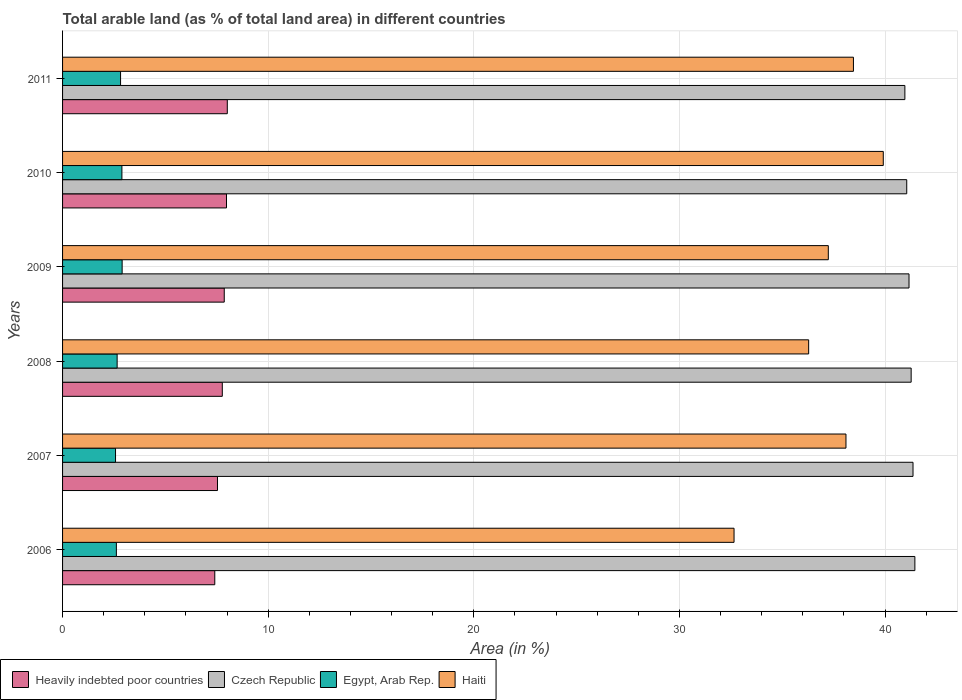How many different coloured bars are there?
Your answer should be compact. 4. How many bars are there on the 4th tick from the top?
Offer a terse response. 4. What is the percentage of arable land in Heavily indebted poor countries in 2009?
Keep it short and to the point. 7.86. Across all years, what is the maximum percentage of arable land in Czech Republic?
Your answer should be compact. 41.45. Across all years, what is the minimum percentage of arable land in Egypt, Arab Rep.?
Keep it short and to the point. 2.58. In which year was the percentage of arable land in Czech Republic minimum?
Your answer should be compact. 2011. What is the total percentage of arable land in Czech Republic in the graph?
Give a very brief answer. 247.26. What is the difference between the percentage of arable land in Egypt, Arab Rep. in 2010 and that in 2011?
Your answer should be compact. 0.07. What is the difference between the percentage of arable land in Haiti in 2010 and the percentage of arable land in Czech Republic in 2008?
Give a very brief answer. -1.36. What is the average percentage of arable land in Egypt, Arab Rep. per year?
Offer a terse response. 2.74. In the year 2008, what is the difference between the percentage of arable land in Heavily indebted poor countries and percentage of arable land in Czech Republic?
Keep it short and to the point. -33.5. In how many years, is the percentage of arable land in Haiti greater than 24 %?
Your answer should be very brief. 6. What is the ratio of the percentage of arable land in Haiti in 2006 to that in 2007?
Give a very brief answer. 0.86. Is the percentage of arable land in Czech Republic in 2008 less than that in 2011?
Make the answer very short. No. What is the difference between the highest and the second highest percentage of arable land in Heavily indebted poor countries?
Provide a short and direct response. 0.04. What is the difference between the highest and the lowest percentage of arable land in Egypt, Arab Rep.?
Your response must be concise. 0.32. What does the 2nd bar from the top in 2007 represents?
Give a very brief answer. Egypt, Arab Rep. What does the 2nd bar from the bottom in 2011 represents?
Make the answer very short. Czech Republic. How many bars are there?
Keep it short and to the point. 24. How many years are there in the graph?
Your response must be concise. 6. What is the difference between two consecutive major ticks on the X-axis?
Your answer should be very brief. 10. Are the values on the major ticks of X-axis written in scientific E-notation?
Make the answer very short. No. Does the graph contain any zero values?
Your response must be concise. No. Does the graph contain grids?
Your answer should be compact. Yes. Where does the legend appear in the graph?
Give a very brief answer. Bottom left. How many legend labels are there?
Give a very brief answer. 4. What is the title of the graph?
Your response must be concise. Total arable land (as % of total land area) in different countries. What is the label or title of the X-axis?
Offer a terse response. Area (in %). What is the label or title of the Y-axis?
Provide a succinct answer. Years. What is the Area (in %) in Heavily indebted poor countries in 2006?
Make the answer very short. 7.4. What is the Area (in %) in Czech Republic in 2006?
Your response must be concise. 41.45. What is the Area (in %) of Egypt, Arab Rep. in 2006?
Your answer should be compact. 2.62. What is the Area (in %) of Haiti in 2006?
Give a very brief answer. 32.66. What is the Area (in %) in Heavily indebted poor countries in 2007?
Provide a succinct answer. 7.53. What is the Area (in %) in Czech Republic in 2007?
Make the answer very short. 41.36. What is the Area (in %) of Egypt, Arab Rep. in 2007?
Offer a terse response. 2.58. What is the Area (in %) in Haiti in 2007?
Your answer should be compact. 38.1. What is the Area (in %) in Heavily indebted poor countries in 2008?
Offer a terse response. 7.77. What is the Area (in %) of Czech Republic in 2008?
Ensure brevity in your answer.  41.27. What is the Area (in %) of Egypt, Arab Rep. in 2008?
Make the answer very short. 2.65. What is the Area (in %) of Haiti in 2008?
Offer a terse response. 36.28. What is the Area (in %) of Heavily indebted poor countries in 2009?
Your answer should be very brief. 7.86. What is the Area (in %) of Czech Republic in 2009?
Provide a short and direct response. 41.17. What is the Area (in %) of Egypt, Arab Rep. in 2009?
Provide a succinct answer. 2.9. What is the Area (in %) of Haiti in 2009?
Provide a succinct answer. 37.24. What is the Area (in %) of Heavily indebted poor countries in 2010?
Your answer should be compact. 7.97. What is the Area (in %) in Czech Republic in 2010?
Offer a very short reply. 41.05. What is the Area (in %) of Egypt, Arab Rep. in 2010?
Your answer should be compact. 2.89. What is the Area (in %) of Haiti in 2010?
Make the answer very short. 39.91. What is the Area (in %) in Heavily indebted poor countries in 2011?
Offer a terse response. 8.01. What is the Area (in %) of Czech Republic in 2011?
Provide a short and direct response. 40.96. What is the Area (in %) in Egypt, Arab Rep. in 2011?
Offer a very short reply. 2.82. What is the Area (in %) of Haiti in 2011?
Ensure brevity in your answer.  38.46. Across all years, what is the maximum Area (in %) of Heavily indebted poor countries?
Ensure brevity in your answer.  8.01. Across all years, what is the maximum Area (in %) of Czech Republic?
Your answer should be compact. 41.45. Across all years, what is the maximum Area (in %) of Egypt, Arab Rep.?
Ensure brevity in your answer.  2.9. Across all years, what is the maximum Area (in %) in Haiti?
Your answer should be compact. 39.91. Across all years, what is the minimum Area (in %) in Heavily indebted poor countries?
Offer a terse response. 7.4. Across all years, what is the minimum Area (in %) in Czech Republic?
Provide a succinct answer. 40.96. Across all years, what is the minimum Area (in %) of Egypt, Arab Rep.?
Make the answer very short. 2.58. Across all years, what is the minimum Area (in %) of Haiti?
Provide a short and direct response. 32.66. What is the total Area (in %) of Heavily indebted poor countries in the graph?
Your answer should be very brief. 46.55. What is the total Area (in %) in Czech Republic in the graph?
Ensure brevity in your answer.  247.26. What is the total Area (in %) in Egypt, Arab Rep. in the graph?
Provide a succinct answer. 16.45. What is the total Area (in %) of Haiti in the graph?
Your response must be concise. 222.65. What is the difference between the Area (in %) in Heavily indebted poor countries in 2006 and that in 2007?
Provide a succinct answer. -0.13. What is the difference between the Area (in %) of Czech Republic in 2006 and that in 2007?
Offer a very short reply. 0.09. What is the difference between the Area (in %) of Egypt, Arab Rep. in 2006 and that in 2007?
Offer a very short reply. 0.04. What is the difference between the Area (in %) of Haiti in 2006 and that in 2007?
Keep it short and to the point. -5.44. What is the difference between the Area (in %) of Heavily indebted poor countries in 2006 and that in 2008?
Provide a succinct answer. -0.37. What is the difference between the Area (in %) in Czech Republic in 2006 and that in 2008?
Keep it short and to the point. 0.18. What is the difference between the Area (in %) of Egypt, Arab Rep. in 2006 and that in 2008?
Ensure brevity in your answer.  -0.04. What is the difference between the Area (in %) of Haiti in 2006 and that in 2008?
Your answer should be very brief. -3.63. What is the difference between the Area (in %) of Heavily indebted poor countries in 2006 and that in 2009?
Your response must be concise. -0.46. What is the difference between the Area (in %) in Czech Republic in 2006 and that in 2009?
Offer a terse response. 0.28. What is the difference between the Area (in %) in Egypt, Arab Rep. in 2006 and that in 2009?
Ensure brevity in your answer.  -0.28. What is the difference between the Area (in %) of Haiti in 2006 and that in 2009?
Offer a very short reply. -4.58. What is the difference between the Area (in %) in Heavily indebted poor countries in 2006 and that in 2010?
Your answer should be compact. -0.57. What is the difference between the Area (in %) in Czech Republic in 2006 and that in 2010?
Provide a short and direct response. 0.4. What is the difference between the Area (in %) in Egypt, Arab Rep. in 2006 and that in 2010?
Give a very brief answer. -0.27. What is the difference between the Area (in %) in Haiti in 2006 and that in 2010?
Ensure brevity in your answer.  -7.26. What is the difference between the Area (in %) of Heavily indebted poor countries in 2006 and that in 2011?
Provide a short and direct response. -0.61. What is the difference between the Area (in %) in Czech Republic in 2006 and that in 2011?
Make the answer very short. 0.49. What is the difference between the Area (in %) of Egypt, Arab Rep. in 2006 and that in 2011?
Provide a succinct answer. -0.2. What is the difference between the Area (in %) of Haiti in 2006 and that in 2011?
Provide a succinct answer. -5.81. What is the difference between the Area (in %) of Heavily indebted poor countries in 2007 and that in 2008?
Provide a short and direct response. -0.23. What is the difference between the Area (in %) of Czech Republic in 2007 and that in 2008?
Offer a very short reply. 0.09. What is the difference between the Area (in %) of Egypt, Arab Rep. in 2007 and that in 2008?
Your answer should be compact. -0.08. What is the difference between the Area (in %) in Haiti in 2007 and that in 2008?
Your answer should be compact. 1.81. What is the difference between the Area (in %) of Heavily indebted poor countries in 2007 and that in 2009?
Provide a succinct answer. -0.33. What is the difference between the Area (in %) in Czech Republic in 2007 and that in 2009?
Keep it short and to the point. 0.19. What is the difference between the Area (in %) of Egypt, Arab Rep. in 2007 and that in 2009?
Provide a short and direct response. -0.32. What is the difference between the Area (in %) of Haiti in 2007 and that in 2009?
Offer a very short reply. 0.86. What is the difference between the Area (in %) of Heavily indebted poor countries in 2007 and that in 2010?
Offer a terse response. -0.44. What is the difference between the Area (in %) in Czech Republic in 2007 and that in 2010?
Give a very brief answer. 0.31. What is the difference between the Area (in %) of Egypt, Arab Rep. in 2007 and that in 2010?
Your answer should be compact. -0.31. What is the difference between the Area (in %) of Haiti in 2007 and that in 2010?
Provide a succinct answer. -1.81. What is the difference between the Area (in %) in Heavily indebted poor countries in 2007 and that in 2011?
Keep it short and to the point. -0.48. What is the difference between the Area (in %) of Czech Republic in 2007 and that in 2011?
Your answer should be compact. 0.4. What is the difference between the Area (in %) of Egypt, Arab Rep. in 2007 and that in 2011?
Keep it short and to the point. -0.25. What is the difference between the Area (in %) in Haiti in 2007 and that in 2011?
Your response must be concise. -0.36. What is the difference between the Area (in %) of Heavily indebted poor countries in 2008 and that in 2009?
Provide a short and direct response. -0.09. What is the difference between the Area (in %) in Czech Republic in 2008 and that in 2009?
Ensure brevity in your answer.  0.1. What is the difference between the Area (in %) of Egypt, Arab Rep. in 2008 and that in 2009?
Give a very brief answer. -0.24. What is the difference between the Area (in %) in Haiti in 2008 and that in 2009?
Ensure brevity in your answer.  -0.96. What is the difference between the Area (in %) in Heavily indebted poor countries in 2008 and that in 2010?
Provide a succinct answer. -0.2. What is the difference between the Area (in %) of Czech Republic in 2008 and that in 2010?
Your answer should be very brief. 0.21. What is the difference between the Area (in %) in Egypt, Arab Rep. in 2008 and that in 2010?
Your response must be concise. -0.23. What is the difference between the Area (in %) in Haiti in 2008 and that in 2010?
Offer a very short reply. -3.63. What is the difference between the Area (in %) in Heavily indebted poor countries in 2008 and that in 2011?
Offer a very short reply. -0.24. What is the difference between the Area (in %) of Czech Republic in 2008 and that in 2011?
Offer a terse response. 0.31. What is the difference between the Area (in %) of Egypt, Arab Rep. in 2008 and that in 2011?
Offer a terse response. -0.17. What is the difference between the Area (in %) of Haiti in 2008 and that in 2011?
Ensure brevity in your answer.  -2.18. What is the difference between the Area (in %) in Heavily indebted poor countries in 2009 and that in 2010?
Your answer should be compact. -0.11. What is the difference between the Area (in %) in Czech Republic in 2009 and that in 2010?
Offer a terse response. 0.11. What is the difference between the Area (in %) in Egypt, Arab Rep. in 2009 and that in 2010?
Provide a succinct answer. 0.01. What is the difference between the Area (in %) of Haiti in 2009 and that in 2010?
Provide a succinct answer. -2.67. What is the difference between the Area (in %) of Heavily indebted poor countries in 2009 and that in 2011?
Provide a short and direct response. -0.15. What is the difference between the Area (in %) of Czech Republic in 2009 and that in 2011?
Ensure brevity in your answer.  0.2. What is the difference between the Area (in %) in Egypt, Arab Rep. in 2009 and that in 2011?
Offer a terse response. 0.08. What is the difference between the Area (in %) of Haiti in 2009 and that in 2011?
Your answer should be very brief. -1.22. What is the difference between the Area (in %) in Heavily indebted poor countries in 2010 and that in 2011?
Provide a short and direct response. -0.04. What is the difference between the Area (in %) in Czech Republic in 2010 and that in 2011?
Offer a terse response. 0.09. What is the difference between the Area (in %) in Egypt, Arab Rep. in 2010 and that in 2011?
Offer a very short reply. 0.07. What is the difference between the Area (in %) in Haiti in 2010 and that in 2011?
Offer a very short reply. 1.45. What is the difference between the Area (in %) of Heavily indebted poor countries in 2006 and the Area (in %) of Czech Republic in 2007?
Make the answer very short. -33.96. What is the difference between the Area (in %) of Heavily indebted poor countries in 2006 and the Area (in %) of Egypt, Arab Rep. in 2007?
Offer a very short reply. 4.83. What is the difference between the Area (in %) in Heavily indebted poor countries in 2006 and the Area (in %) in Haiti in 2007?
Your answer should be very brief. -30.7. What is the difference between the Area (in %) of Czech Republic in 2006 and the Area (in %) of Egypt, Arab Rep. in 2007?
Ensure brevity in your answer.  38.87. What is the difference between the Area (in %) in Czech Republic in 2006 and the Area (in %) in Haiti in 2007?
Give a very brief answer. 3.35. What is the difference between the Area (in %) in Egypt, Arab Rep. in 2006 and the Area (in %) in Haiti in 2007?
Offer a very short reply. -35.48. What is the difference between the Area (in %) in Heavily indebted poor countries in 2006 and the Area (in %) in Czech Republic in 2008?
Your answer should be compact. -33.87. What is the difference between the Area (in %) in Heavily indebted poor countries in 2006 and the Area (in %) in Egypt, Arab Rep. in 2008?
Your answer should be compact. 4.75. What is the difference between the Area (in %) of Heavily indebted poor countries in 2006 and the Area (in %) of Haiti in 2008?
Provide a succinct answer. -28.88. What is the difference between the Area (in %) in Czech Republic in 2006 and the Area (in %) in Egypt, Arab Rep. in 2008?
Keep it short and to the point. 38.8. What is the difference between the Area (in %) of Czech Republic in 2006 and the Area (in %) of Haiti in 2008?
Make the answer very short. 5.17. What is the difference between the Area (in %) in Egypt, Arab Rep. in 2006 and the Area (in %) in Haiti in 2008?
Give a very brief answer. -33.67. What is the difference between the Area (in %) of Heavily indebted poor countries in 2006 and the Area (in %) of Czech Republic in 2009?
Keep it short and to the point. -33.76. What is the difference between the Area (in %) of Heavily indebted poor countries in 2006 and the Area (in %) of Egypt, Arab Rep. in 2009?
Your answer should be very brief. 4.51. What is the difference between the Area (in %) in Heavily indebted poor countries in 2006 and the Area (in %) in Haiti in 2009?
Provide a succinct answer. -29.84. What is the difference between the Area (in %) in Czech Republic in 2006 and the Area (in %) in Egypt, Arab Rep. in 2009?
Make the answer very short. 38.55. What is the difference between the Area (in %) in Czech Republic in 2006 and the Area (in %) in Haiti in 2009?
Offer a very short reply. 4.21. What is the difference between the Area (in %) in Egypt, Arab Rep. in 2006 and the Area (in %) in Haiti in 2009?
Provide a short and direct response. -34.62. What is the difference between the Area (in %) of Heavily indebted poor countries in 2006 and the Area (in %) of Czech Republic in 2010?
Your response must be concise. -33.65. What is the difference between the Area (in %) of Heavily indebted poor countries in 2006 and the Area (in %) of Egypt, Arab Rep. in 2010?
Keep it short and to the point. 4.52. What is the difference between the Area (in %) of Heavily indebted poor countries in 2006 and the Area (in %) of Haiti in 2010?
Keep it short and to the point. -32.51. What is the difference between the Area (in %) of Czech Republic in 2006 and the Area (in %) of Egypt, Arab Rep. in 2010?
Give a very brief answer. 38.56. What is the difference between the Area (in %) in Czech Republic in 2006 and the Area (in %) in Haiti in 2010?
Offer a terse response. 1.54. What is the difference between the Area (in %) in Egypt, Arab Rep. in 2006 and the Area (in %) in Haiti in 2010?
Your answer should be very brief. -37.3. What is the difference between the Area (in %) in Heavily indebted poor countries in 2006 and the Area (in %) in Czech Republic in 2011?
Ensure brevity in your answer.  -33.56. What is the difference between the Area (in %) of Heavily indebted poor countries in 2006 and the Area (in %) of Egypt, Arab Rep. in 2011?
Offer a very short reply. 4.58. What is the difference between the Area (in %) in Heavily indebted poor countries in 2006 and the Area (in %) in Haiti in 2011?
Make the answer very short. -31.06. What is the difference between the Area (in %) of Czech Republic in 2006 and the Area (in %) of Egypt, Arab Rep. in 2011?
Ensure brevity in your answer.  38.63. What is the difference between the Area (in %) in Czech Republic in 2006 and the Area (in %) in Haiti in 2011?
Offer a very short reply. 2.99. What is the difference between the Area (in %) of Egypt, Arab Rep. in 2006 and the Area (in %) of Haiti in 2011?
Offer a terse response. -35.84. What is the difference between the Area (in %) of Heavily indebted poor countries in 2007 and the Area (in %) of Czech Republic in 2008?
Provide a short and direct response. -33.73. What is the difference between the Area (in %) of Heavily indebted poor countries in 2007 and the Area (in %) of Egypt, Arab Rep. in 2008?
Offer a very short reply. 4.88. What is the difference between the Area (in %) in Heavily indebted poor countries in 2007 and the Area (in %) in Haiti in 2008?
Offer a very short reply. -28.75. What is the difference between the Area (in %) of Czech Republic in 2007 and the Area (in %) of Egypt, Arab Rep. in 2008?
Offer a terse response. 38.71. What is the difference between the Area (in %) of Czech Republic in 2007 and the Area (in %) of Haiti in 2008?
Keep it short and to the point. 5.07. What is the difference between the Area (in %) of Egypt, Arab Rep. in 2007 and the Area (in %) of Haiti in 2008?
Keep it short and to the point. -33.71. What is the difference between the Area (in %) in Heavily indebted poor countries in 2007 and the Area (in %) in Czech Republic in 2009?
Give a very brief answer. -33.63. What is the difference between the Area (in %) of Heavily indebted poor countries in 2007 and the Area (in %) of Egypt, Arab Rep. in 2009?
Provide a succinct answer. 4.64. What is the difference between the Area (in %) of Heavily indebted poor countries in 2007 and the Area (in %) of Haiti in 2009?
Your answer should be compact. -29.71. What is the difference between the Area (in %) of Czech Republic in 2007 and the Area (in %) of Egypt, Arab Rep. in 2009?
Offer a very short reply. 38.46. What is the difference between the Area (in %) in Czech Republic in 2007 and the Area (in %) in Haiti in 2009?
Ensure brevity in your answer.  4.12. What is the difference between the Area (in %) of Egypt, Arab Rep. in 2007 and the Area (in %) of Haiti in 2009?
Give a very brief answer. -34.66. What is the difference between the Area (in %) in Heavily indebted poor countries in 2007 and the Area (in %) in Czech Republic in 2010?
Your response must be concise. -33.52. What is the difference between the Area (in %) in Heavily indebted poor countries in 2007 and the Area (in %) in Egypt, Arab Rep. in 2010?
Keep it short and to the point. 4.65. What is the difference between the Area (in %) in Heavily indebted poor countries in 2007 and the Area (in %) in Haiti in 2010?
Your answer should be very brief. -32.38. What is the difference between the Area (in %) of Czech Republic in 2007 and the Area (in %) of Egypt, Arab Rep. in 2010?
Your answer should be compact. 38.47. What is the difference between the Area (in %) in Czech Republic in 2007 and the Area (in %) in Haiti in 2010?
Your answer should be very brief. 1.45. What is the difference between the Area (in %) in Egypt, Arab Rep. in 2007 and the Area (in %) in Haiti in 2010?
Your response must be concise. -37.34. What is the difference between the Area (in %) in Heavily indebted poor countries in 2007 and the Area (in %) in Czech Republic in 2011?
Provide a succinct answer. -33.43. What is the difference between the Area (in %) of Heavily indebted poor countries in 2007 and the Area (in %) of Egypt, Arab Rep. in 2011?
Your answer should be compact. 4.71. What is the difference between the Area (in %) in Heavily indebted poor countries in 2007 and the Area (in %) in Haiti in 2011?
Provide a short and direct response. -30.93. What is the difference between the Area (in %) of Czech Republic in 2007 and the Area (in %) of Egypt, Arab Rep. in 2011?
Offer a terse response. 38.54. What is the difference between the Area (in %) in Czech Republic in 2007 and the Area (in %) in Haiti in 2011?
Your response must be concise. 2.9. What is the difference between the Area (in %) of Egypt, Arab Rep. in 2007 and the Area (in %) of Haiti in 2011?
Ensure brevity in your answer.  -35.89. What is the difference between the Area (in %) of Heavily indebted poor countries in 2008 and the Area (in %) of Czech Republic in 2009?
Ensure brevity in your answer.  -33.4. What is the difference between the Area (in %) of Heavily indebted poor countries in 2008 and the Area (in %) of Egypt, Arab Rep. in 2009?
Your answer should be very brief. 4.87. What is the difference between the Area (in %) in Heavily indebted poor countries in 2008 and the Area (in %) in Haiti in 2009?
Provide a short and direct response. -29.47. What is the difference between the Area (in %) of Czech Republic in 2008 and the Area (in %) of Egypt, Arab Rep. in 2009?
Your answer should be very brief. 38.37. What is the difference between the Area (in %) in Czech Republic in 2008 and the Area (in %) in Haiti in 2009?
Ensure brevity in your answer.  4.03. What is the difference between the Area (in %) in Egypt, Arab Rep. in 2008 and the Area (in %) in Haiti in 2009?
Your answer should be very brief. -34.59. What is the difference between the Area (in %) of Heavily indebted poor countries in 2008 and the Area (in %) of Czech Republic in 2010?
Make the answer very short. -33.29. What is the difference between the Area (in %) in Heavily indebted poor countries in 2008 and the Area (in %) in Egypt, Arab Rep. in 2010?
Your answer should be very brief. 4.88. What is the difference between the Area (in %) in Heavily indebted poor countries in 2008 and the Area (in %) in Haiti in 2010?
Your answer should be compact. -32.14. What is the difference between the Area (in %) of Czech Republic in 2008 and the Area (in %) of Egypt, Arab Rep. in 2010?
Offer a terse response. 38.38. What is the difference between the Area (in %) of Czech Republic in 2008 and the Area (in %) of Haiti in 2010?
Keep it short and to the point. 1.36. What is the difference between the Area (in %) of Egypt, Arab Rep. in 2008 and the Area (in %) of Haiti in 2010?
Your answer should be very brief. -37.26. What is the difference between the Area (in %) in Heavily indebted poor countries in 2008 and the Area (in %) in Czech Republic in 2011?
Offer a very short reply. -33.19. What is the difference between the Area (in %) in Heavily indebted poor countries in 2008 and the Area (in %) in Egypt, Arab Rep. in 2011?
Ensure brevity in your answer.  4.95. What is the difference between the Area (in %) in Heavily indebted poor countries in 2008 and the Area (in %) in Haiti in 2011?
Provide a short and direct response. -30.69. What is the difference between the Area (in %) in Czech Republic in 2008 and the Area (in %) in Egypt, Arab Rep. in 2011?
Your response must be concise. 38.45. What is the difference between the Area (in %) in Czech Republic in 2008 and the Area (in %) in Haiti in 2011?
Make the answer very short. 2.81. What is the difference between the Area (in %) in Egypt, Arab Rep. in 2008 and the Area (in %) in Haiti in 2011?
Ensure brevity in your answer.  -35.81. What is the difference between the Area (in %) in Heavily indebted poor countries in 2009 and the Area (in %) in Czech Republic in 2010?
Your answer should be very brief. -33.19. What is the difference between the Area (in %) of Heavily indebted poor countries in 2009 and the Area (in %) of Egypt, Arab Rep. in 2010?
Offer a very short reply. 4.98. What is the difference between the Area (in %) of Heavily indebted poor countries in 2009 and the Area (in %) of Haiti in 2010?
Give a very brief answer. -32.05. What is the difference between the Area (in %) of Czech Republic in 2009 and the Area (in %) of Egypt, Arab Rep. in 2010?
Make the answer very short. 38.28. What is the difference between the Area (in %) of Czech Republic in 2009 and the Area (in %) of Haiti in 2010?
Give a very brief answer. 1.25. What is the difference between the Area (in %) of Egypt, Arab Rep. in 2009 and the Area (in %) of Haiti in 2010?
Make the answer very short. -37.02. What is the difference between the Area (in %) in Heavily indebted poor countries in 2009 and the Area (in %) in Czech Republic in 2011?
Offer a terse response. -33.1. What is the difference between the Area (in %) of Heavily indebted poor countries in 2009 and the Area (in %) of Egypt, Arab Rep. in 2011?
Your answer should be very brief. 5.04. What is the difference between the Area (in %) in Heavily indebted poor countries in 2009 and the Area (in %) in Haiti in 2011?
Offer a terse response. -30.6. What is the difference between the Area (in %) in Czech Republic in 2009 and the Area (in %) in Egypt, Arab Rep. in 2011?
Provide a short and direct response. 38.34. What is the difference between the Area (in %) in Czech Republic in 2009 and the Area (in %) in Haiti in 2011?
Provide a short and direct response. 2.7. What is the difference between the Area (in %) in Egypt, Arab Rep. in 2009 and the Area (in %) in Haiti in 2011?
Provide a succinct answer. -35.56. What is the difference between the Area (in %) in Heavily indebted poor countries in 2010 and the Area (in %) in Czech Republic in 2011?
Provide a succinct answer. -32.99. What is the difference between the Area (in %) in Heavily indebted poor countries in 2010 and the Area (in %) in Egypt, Arab Rep. in 2011?
Make the answer very short. 5.15. What is the difference between the Area (in %) in Heavily indebted poor countries in 2010 and the Area (in %) in Haiti in 2011?
Your response must be concise. -30.49. What is the difference between the Area (in %) in Czech Republic in 2010 and the Area (in %) in Egypt, Arab Rep. in 2011?
Provide a short and direct response. 38.23. What is the difference between the Area (in %) of Czech Republic in 2010 and the Area (in %) of Haiti in 2011?
Make the answer very short. 2.59. What is the difference between the Area (in %) in Egypt, Arab Rep. in 2010 and the Area (in %) in Haiti in 2011?
Your answer should be very brief. -35.58. What is the average Area (in %) in Heavily indebted poor countries per year?
Give a very brief answer. 7.76. What is the average Area (in %) in Czech Republic per year?
Provide a short and direct response. 41.21. What is the average Area (in %) of Egypt, Arab Rep. per year?
Offer a terse response. 2.74. What is the average Area (in %) in Haiti per year?
Give a very brief answer. 37.11. In the year 2006, what is the difference between the Area (in %) in Heavily indebted poor countries and Area (in %) in Czech Republic?
Provide a short and direct response. -34.05. In the year 2006, what is the difference between the Area (in %) in Heavily indebted poor countries and Area (in %) in Egypt, Arab Rep.?
Provide a short and direct response. 4.79. In the year 2006, what is the difference between the Area (in %) of Heavily indebted poor countries and Area (in %) of Haiti?
Your answer should be very brief. -25.25. In the year 2006, what is the difference between the Area (in %) in Czech Republic and Area (in %) in Egypt, Arab Rep.?
Provide a short and direct response. 38.83. In the year 2006, what is the difference between the Area (in %) of Czech Republic and Area (in %) of Haiti?
Your answer should be compact. 8.79. In the year 2006, what is the difference between the Area (in %) of Egypt, Arab Rep. and Area (in %) of Haiti?
Ensure brevity in your answer.  -30.04. In the year 2007, what is the difference between the Area (in %) in Heavily indebted poor countries and Area (in %) in Czech Republic?
Make the answer very short. -33.83. In the year 2007, what is the difference between the Area (in %) of Heavily indebted poor countries and Area (in %) of Egypt, Arab Rep.?
Give a very brief answer. 4.96. In the year 2007, what is the difference between the Area (in %) of Heavily indebted poor countries and Area (in %) of Haiti?
Give a very brief answer. -30.56. In the year 2007, what is the difference between the Area (in %) in Czech Republic and Area (in %) in Egypt, Arab Rep.?
Your response must be concise. 38.78. In the year 2007, what is the difference between the Area (in %) in Czech Republic and Area (in %) in Haiti?
Your answer should be compact. 3.26. In the year 2007, what is the difference between the Area (in %) in Egypt, Arab Rep. and Area (in %) in Haiti?
Make the answer very short. -35.52. In the year 2008, what is the difference between the Area (in %) of Heavily indebted poor countries and Area (in %) of Czech Republic?
Offer a very short reply. -33.5. In the year 2008, what is the difference between the Area (in %) of Heavily indebted poor countries and Area (in %) of Egypt, Arab Rep.?
Your answer should be compact. 5.11. In the year 2008, what is the difference between the Area (in %) of Heavily indebted poor countries and Area (in %) of Haiti?
Give a very brief answer. -28.52. In the year 2008, what is the difference between the Area (in %) of Czech Republic and Area (in %) of Egypt, Arab Rep.?
Provide a short and direct response. 38.61. In the year 2008, what is the difference between the Area (in %) in Czech Republic and Area (in %) in Haiti?
Make the answer very short. 4.98. In the year 2008, what is the difference between the Area (in %) of Egypt, Arab Rep. and Area (in %) of Haiti?
Keep it short and to the point. -33.63. In the year 2009, what is the difference between the Area (in %) of Heavily indebted poor countries and Area (in %) of Czech Republic?
Your answer should be very brief. -33.3. In the year 2009, what is the difference between the Area (in %) in Heavily indebted poor countries and Area (in %) in Egypt, Arab Rep.?
Offer a terse response. 4.97. In the year 2009, what is the difference between the Area (in %) in Heavily indebted poor countries and Area (in %) in Haiti?
Keep it short and to the point. -29.38. In the year 2009, what is the difference between the Area (in %) of Czech Republic and Area (in %) of Egypt, Arab Rep.?
Your answer should be very brief. 38.27. In the year 2009, what is the difference between the Area (in %) in Czech Republic and Area (in %) in Haiti?
Make the answer very short. 3.93. In the year 2009, what is the difference between the Area (in %) of Egypt, Arab Rep. and Area (in %) of Haiti?
Keep it short and to the point. -34.34. In the year 2010, what is the difference between the Area (in %) of Heavily indebted poor countries and Area (in %) of Czech Republic?
Offer a terse response. -33.08. In the year 2010, what is the difference between the Area (in %) in Heavily indebted poor countries and Area (in %) in Egypt, Arab Rep.?
Offer a terse response. 5.09. In the year 2010, what is the difference between the Area (in %) in Heavily indebted poor countries and Area (in %) in Haiti?
Your answer should be very brief. -31.94. In the year 2010, what is the difference between the Area (in %) in Czech Republic and Area (in %) in Egypt, Arab Rep.?
Your response must be concise. 38.17. In the year 2010, what is the difference between the Area (in %) of Czech Republic and Area (in %) of Haiti?
Your response must be concise. 1.14. In the year 2010, what is the difference between the Area (in %) of Egypt, Arab Rep. and Area (in %) of Haiti?
Offer a terse response. -37.03. In the year 2011, what is the difference between the Area (in %) in Heavily indebted poor countries and Area (in %) in Czech Republic?
Offer a very short reply. -32.95. In the year 2011, what is the difference between the Area (in %) in Heavily indebted poor countries and Area (in %) in Egypt, Arab Rep.?
Offer a very short reply. 5.19. In the year 2011, what is the difference between the Area (in %) of Heavily indebted poor countries and Area (in %) of Haiti?
Offer a terse response. -30.45. In the year 2011, what is the difference between the Area (in %) of Czech Republic and Area (in %) of Egypt, Arab Rep.?
Your answer should be compact. 38.14. In the year 2011, what is the difference between the Area (in %) in Czech Republic and Area (in %) in Haiti?
Make the answer very short. 2.5. In the year 2011, what is the difference between the Area (in %) of Egypt, Arab Rep. and Area (in %) of Haiti?
Give a very brief answer. -35.64. What is the ratio of the Area (in %) in Heavily indebted poor countries in 2006 to that in 2007?
Make the answer very short. 0.98. What is the ratio of the Area (in %) in Heavily indebted poor countries in 2006 to that in 2008?
Provide a short and direct response. 0.95. What is the ratio of the Area (in %) in Egypt, Arab Rep. in 2006 to that in 2008?
Your answer should be compact. 0.99. What is the ratio of the Area (in %) of Heavily indebted poor countries in 2006 to that in 2009?
Offer a terse response. 0.94. What is the ratio of the Area (in %) in Egypt, Arab Rep. in 2006 to that in 2009?
Offer a very short reply. 0.9. What is the ratio of the Area (in %) in Haiti in 2006 to that in 2009?
Provide a short and direct response. 0.88. What is the ratio of the Area (in %) of Heavily indebted poor countries in 2006 to that in 2010?
Your answer should be compact. 0.93. What is the ratio of the Area (in %) in Czech Republic in 2006 to that in 2010?
Give a very brief answer. 1.01. What is the ratio of the Area (in %) in Egypt, Arab Rep. in 2006 to that in 2010?
Offer a terse response. 0.91. What is the ratio of the Area (in %) of Haiti in 2006 to that in 2010?
Your answer should be compact. 0.82. What is the ratio of the Area (in %) in Heavily indebted poor countries in 2006 to that in 2011?
Make the answer very short. 0.92. What is the ratio of the Area (in %) in Czech Republic in 2006 to that in 2011?
Ensure brevity in your answer.  1.01. What is the ratio of the Area (in %) of Egypt, Arab Rep. in 2006 to that in 2011?
Your answer should be compact. 0.93. What is the ratio of the Area (in %) in Haiti in 2006 to that in 2011?
Provide a succinct answer. 0.85. What is the ratio of the Area (in %) in Heavily indebted poor countries in 2007 to that in 2008?
Provide a succinct answer. 0.97. What is the ratio of the Area (in %) of Czech Republic in 2007 to that in 2008?
Your answer should be very brief. 1. What is the ratio of the Area (in %) in Egypt, Arab Rep. in 2007 to that in 2008?
Provide a succinct answer. 0.97. What is the ratio of the Area (in %) of Haiti in 2007 to that in 2008?
Ensure brevity in your answer.  1.05. What is the ratio of the Area (in %) of Heavily indebted poor countries in 2007 to that in 2009?
Give a very brief answer. 0.96. What is the ratio of the Area (in %) in Egypt, Arab Rep. in 2007 to that in 2009?
Provide a succinct answer. 0.89. What is the ratio of the Area (in %) of Haiti in 2007 to that in 2009?
Offer a very short reply. 1.02. What is the ratio of the Area (in %) in Heavily indebted poor countries in 2007 to that in 2010?
Provide a succinct answer. 0.94. What is the ratio of the Area (in %) of Czech Republic in 2007 to that in 2010?
Your answer should be very brief. 1.01. What is the ratio of the Area (in %) of Egypt, Arab Rep. in 2007 to that in 2010?
Your answer should be very brief. 0.89. What is the ratio of the Area (in %) in Haiti in 2007 to that in 2010?
Provide a short and direct response. 0.95. What is the ratio of the Area (in %) in Heavily indebted poor countries in 2007 to that in 2011?
Offer a terse response. 0.94. What is the ratio of the Area (in %) of Czech Republic in 2007 to that in 2011?
Offer a terse response. 1.01. What is the ratio of the Area (in %) of Egypt, Arab Rep. in 2007 to that in 2011?
Keep it short and to the point. 0.91. What is the ratio of the Area (in %) in Haiti in 2007 to that in 2011?
Your response must be concise. 0.99. What is the ratio of the Area (in %) of Heavily indebted poor countries in 2008 to that in 2009?
Your response must be concise. 0.99. What is the ratio of the Area (in %) in Czech Republic in 2008 to that in 2009?
Your answer should be compact. 1. What is the ratio of the Area (in %) in Egypt, Arab Rep. in 2008 to that in 2009?
Your answer should be very brief. 0.92. What is the ratio of the Area (in %) of Haiti in 2008 to that in 2009?
Offer a very short reply. 0.97. What is the ratio of the Area (in %) of Heavily indebted poor countries in 2008 to that in 2010?
Your answer should be compact. 0.97. What is the ratio of the Area (in %) of Czech Republic in 2008 to that in 2010?
Your answer should be very brief. 1.01. What is the ratio of the Area (in %) of Egypt, Arab Rep. in 2008 to that in 2010?
Give a very brief answer. 0.92. What is the ratio of the Area (in %) of Haiti in 2008 to that in 2010?
Provide a succinct answer. 0.91. What is the ratio of the Area (in %) of Heavily indebted poor countries in 2008 to that in 2011?
Provide a short and direct response. 0.97. What is the ratio of the Area (in %) in Czech Republic in 2008 to that in 2011?
Ensure brevity in your answer.  1.01. What is the ratio of the Area (in %) of Egypt, Arab Rep. in 2008 to that in 2011?
Ensure brevity in your answer.  0.94. What is the ratio of the Area (in %) of Haiti in 2008 to that in 2011?
Offer a very short reply. 0.94. What is the ratio of the Area (in %) in Heavily indebted poor countries in 2009 to that in 2010?
Provide a succinct answer. 0.99. What is the ratio of the Area (in %) in Haiti in 2009 to that in 2010?
Your answer should be compact. 0.93. What is the ratio of the Area (in %) in Heavily indebted poor countries in 2009 to that in 2011?
Your answer should be compact. 0.98. What is the ratio of the Area (in %) in Czech Republic in 2009 to that in 2011?
Your answer should be very brief. 1. What is the ratio of the Area (in %) of Egypt, Arab Rep. in 2009 to that in 2011?
Offer a terse response. 1.03. What is the ratio of the Area (in %) in Haiti in 2009 to that in 2011?
Give a very brief answer. 0.97. What is the ratio of the Area (in %) in Heavily indebted poor countries in 2010 to that in 2011?
Ensure brevity in your answer.  1. What is the ratio of the Area (in %) in Czech Republic in 2010 to that in 2011?
Make the answer very short. 1. What is the ratio of the Area (in %) of Egypt, Arab Rep. in 2010 to that in 2011?
Give a very brief answer. 1.02. What is the ratio of the Area (in %) in Haiti in 2010 to that in 2011?
Make the answer very short. 1.04. What is the difference between the highest and the second highest Area (in %) of Heavily indebted poor countries?
Ensure brevity in your answer.  0.04. What is the difference between the highest and the second highest Area (in %) of Czech Republic?
Your answer should be very brief. 0.09. What is the difference between the highest and the second highest Area (in %) of Egypt, Arab Rep.?
Offer a very short reply. 0.01. What is the difference between the highest and the second highest Area (in %) in Haiti?
Give a very brief answer. 1.45. What is the difference between the highest and the lowest Area (in %) in Heavily indebted poor countries?
Provide a short and direct response. 0.61. What is the difference between the highest and the lowest Area (in %) of Czech Republic?
Your answer should be very brief. 0.49. What is the difference between the highest and the lowest Area (in %) of Egypt, Arab Rep.?
Give a very brief answer. 0.32. What is the difference between the highest and the lowest Area (in %) in Haiti?
Ensure brevity in your answer.  7.26. 